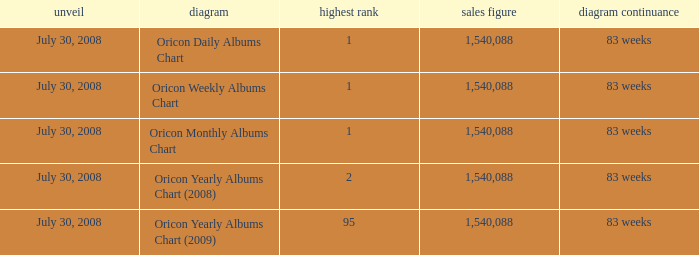How much Peak Position has Sales Total larger than 1,540,088? 0.0. 